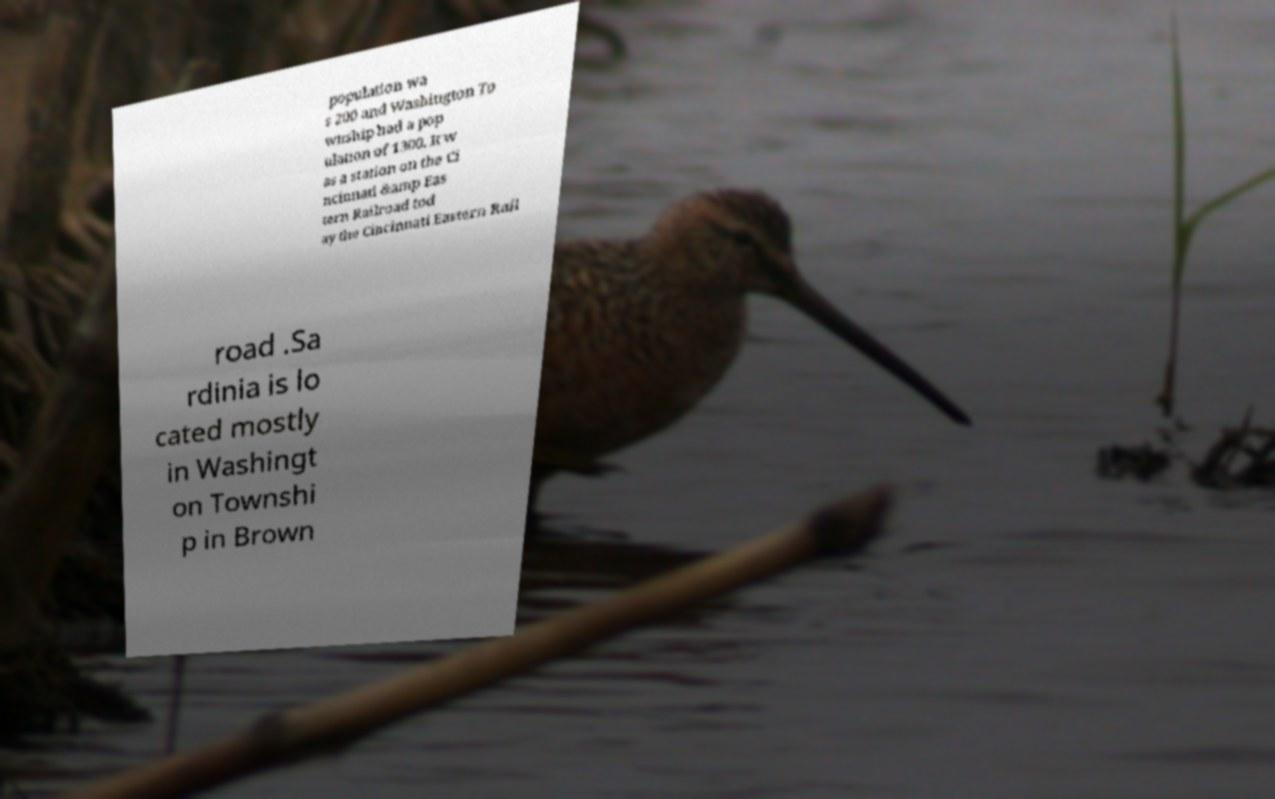Could you assist in decoding the text presented in this image and type it out clearly? population wa s 200 and Washington To wnship had a pop ulation of 1300. It w as a station on the Ci ncinnati &amp Eas tern Railroad tod ay the Cincinnati Eastern Rail road .Sa rdinia is lo cated mostly in Washingt on Townshi p in Brown 